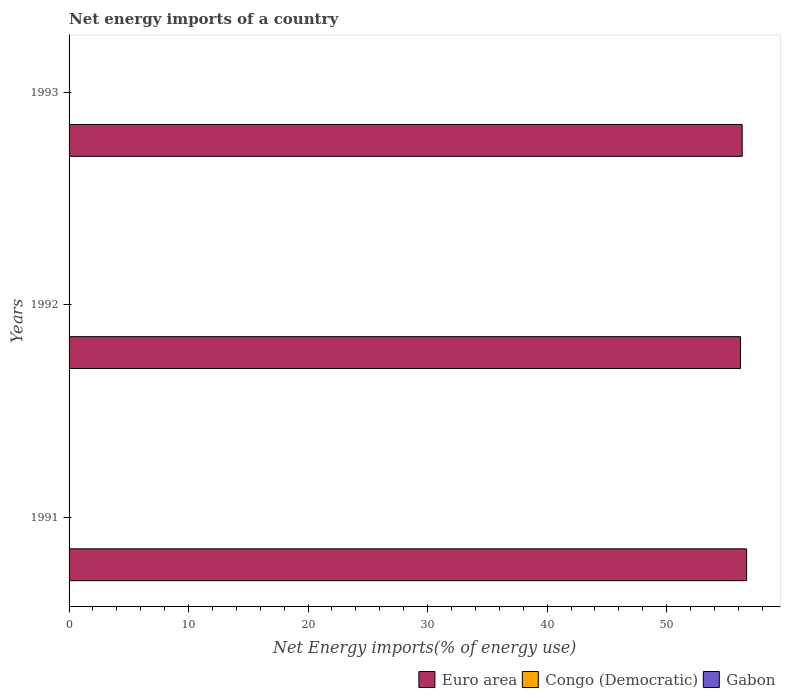Are the number of bars per tick equal to the number of legend labels?
Offer a very short reply. No. What is the net energy imports in Congo (Democratic) in 1993?
Your answer should be very brief. 0. Across all years, what is the maximum net energy imports in Euro area?
Provide a succinct answer. 56.7. What is the total net energy imports in Congo (Democratic) in the graph?
Offer a terse response. 0. What is the difference between the net energy imports in Euro area in 1991 and that in 1992?
Give a very brief answer. 0.51. What is the difference between the net energy imports in Euro area in 1992 and the net energy imports in Gabon in 1991?
Provide a succinct answer. 56.18. What is the ratio of the net energy imports in Euro area in 1991 to that in 1992?
Provide a succinct answer. 1.01. What is the difference between the highest and the lowest net energy imports in Euro area?
Give a very brief answer. 0.51. In how many years, is the net energy imports in Congo (Democratic) greater than the average net energy imports in Congo (Democratic) taken over all years?
Your answer should be compact. 0. Is it the case that in every year, the sum of the net energy imports in Congo (Democratic) and net energy imports in Euro area is greater than the net energy imports in Gabon?
Offer a terse response. Yes. Are the values on the major ticks of X-axis written in scientific E-notation?
Offer a terse response. No. Does the graph contain grids?
Your answer should be compact. No. Where does the legend appear in the graph?
Offer a terse response. Bottom right. How are the legend labels stacked?
Give a very brief answer. Horizontal. What is the title of the graph?
Your answer should be compact. Net energy imports of a country. What is the label or title of the X-axis?
Your response must be concise. Net Energy imports(% of energy use). What is the Net Energy imports(% of energy use) of Euro area in 1991?
Provide a succinct answer. 56.7. What is the Net Energy imports(% of energy use) of Congo (Democratic) in 1991?
Give a very brief answer. 0. What is the Net Energy imports(% of energy use) in Euro area in 1992?
Give a very brief answer. 56.18. What is the Net Energy imports(% of energy use) in Congo (Democratic) in 1992?
Offer a very short reply. 0. What is the Net Energy imports(% of energy use) in Gabon in 1992?
Provide a succinct answer. 0. What is the Net Energy imports(% of energy use) of Euro area in 1993?
Keep it short and to the point. 56.32. What is the Net Energy imports(% of energy use) of Congo (Democratic) in 1993?
Your answer should be very brief. 0. Across all years, what is the maximum Net Energy imports(% of energy use) of Euro area?
Provide a succinct answer. 56.7. Across all years, what is the minimum Net Energy imports(% of energy use) in Euro area?
Offer a terse response. 56.18. What is the total Net Energy imports(% of energy use) in Euro area in the graph?
Make the answer very short. 169.2. What is the total Net Energy imports(% of energy use) in Gabon in the graph?
Offer a terse response. 0. What is the difference between the Net Energy imports(% of energy use) of Euro area in 1991 and that in 1992?
Your answer should be compact. 0.51. What is the difference between the Net Energy imports(% of energy use) of Euro area in 1991 and that in 1993?
Ensure brevity in your answer.  0.37. What is the difference between the Net Energy imports(% of energy use) of Euro area in 1992 and that in 1993?
Offer a terse response. -0.14. What is the average Net Energy imports(% of energy use) of Euro area per year?
Offer a very short reply. 56.4. What is the average Net Energy imports(% of energy use) of Congo (Democratic) per year?
Offer a very short reply. 0. What is the average Net Energy imports(% of energy use) in Gabon per year?
Make the answer very short. 0. What is the ratio of the Net Energy imports(% of energy use) in Euro area in 1991 to that in 1992?
Your response must be concise. 1.01. What is the ratio of the Net Energy imports(% of energy use) in Euro area in 1991 to that in 1993?
Offer a very short reply. 1.01. What is the difference between the highest and the second highest Net Energy imports(% of energy use) in Euro area?
Your answer should be compact. 0.37. What is the difference between the highest and the lowest Net Energy imports(% of energy use) in Euro area?
Ensure brevity in your answer.  0.51. 